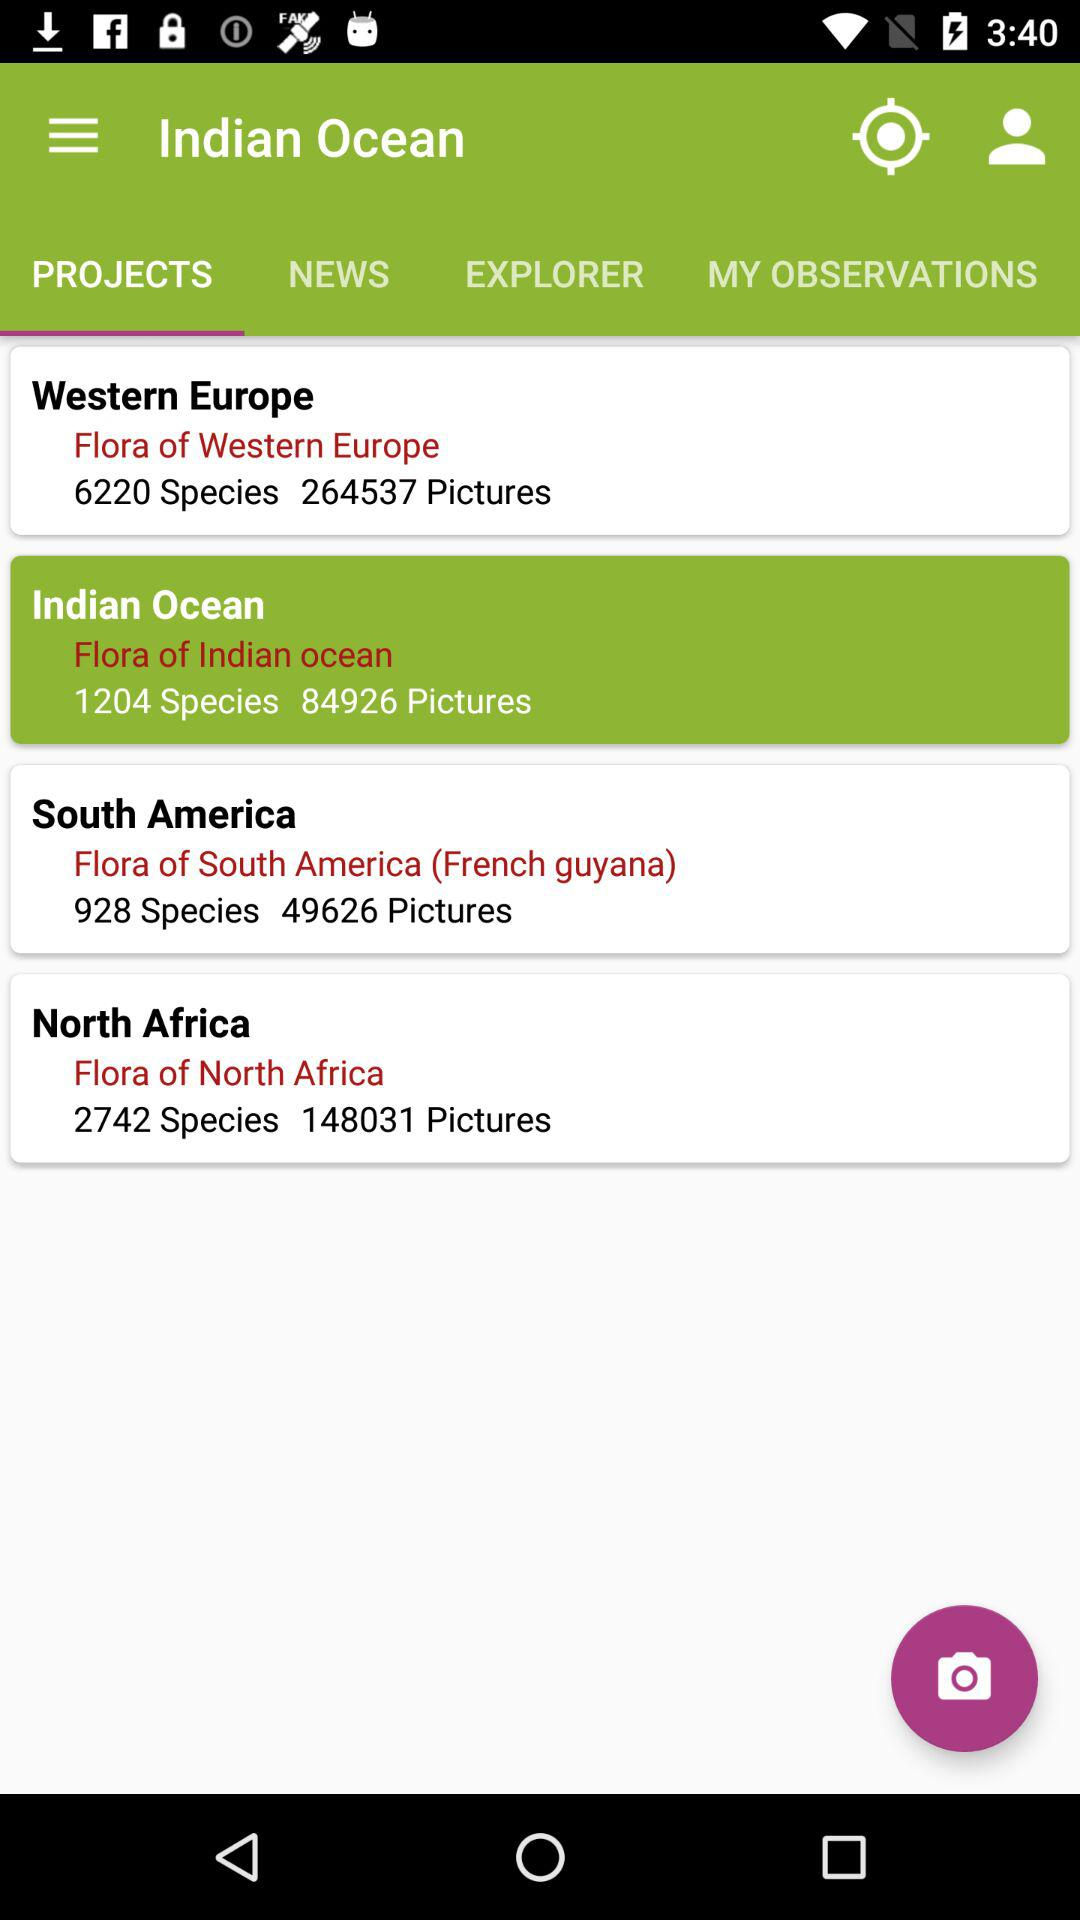How many pictures are there in "Western Europe"? There are 264537 pictures in "Western Europe". 